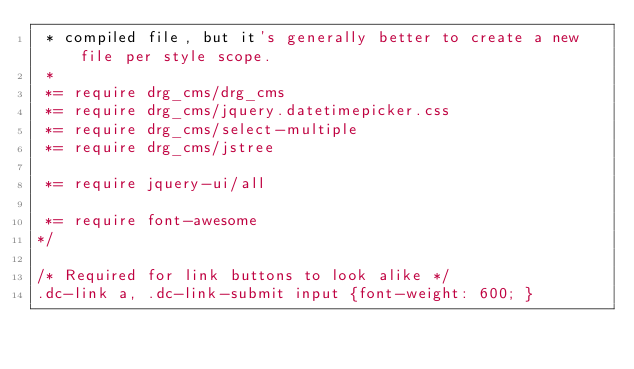Convert code to text. <code><loc_0><loc_0><loc_500><loc_500><_CSS_> * compiled file, but it's generally better to create a new file per style scope.
 *
 *= require drg_cms/drg_cms
 *= require drg_cms/jquery.datetimepicker.css
 *= require drg_cms/select-multiple
 *= require drg_cms/jstree

 *= require jquery-ui/all
 
 *= require font-awesome
*/

/* Required for link buttons to look alike */
.dc-link a, .dc-link-submit input {font-weight: 600; }   
</code> 